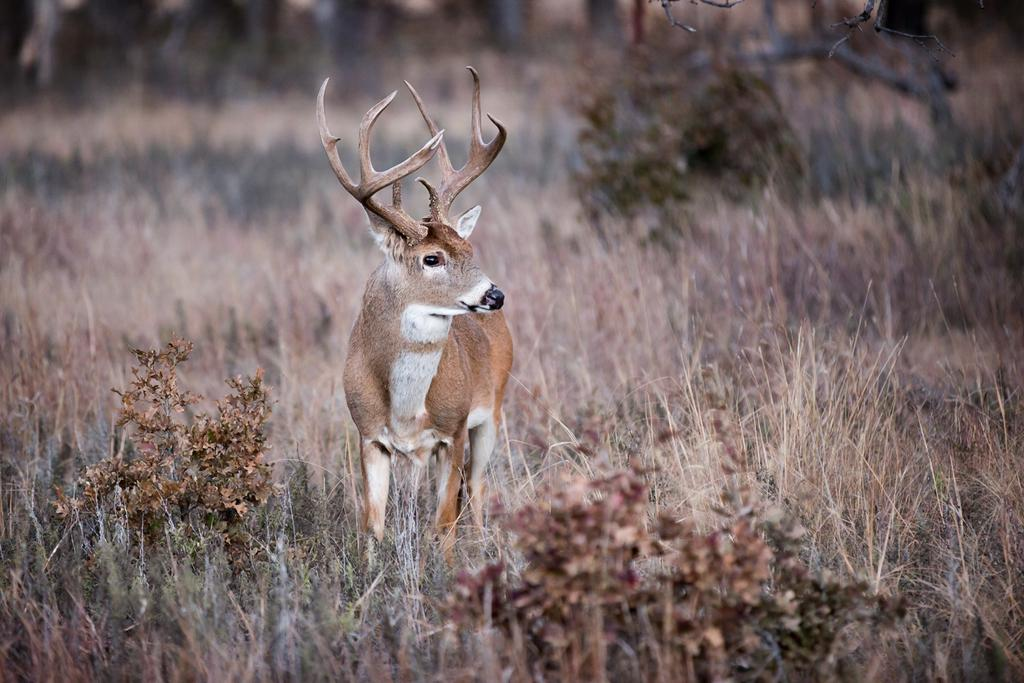What animal can be seen in the image? There is a deer in the image. What is the deer's position in the image? The deer is standing in the dry grass. What type of vegetation is present at the bottom of the image? Small plants are present at the bottom of the image. What is the condition of the grass in the image? Dry grass is visible in the image. How does the deer plan to take a bath in the image? The deer does not plan to take a bath in the image, as there is no water or indication of bathing present. 